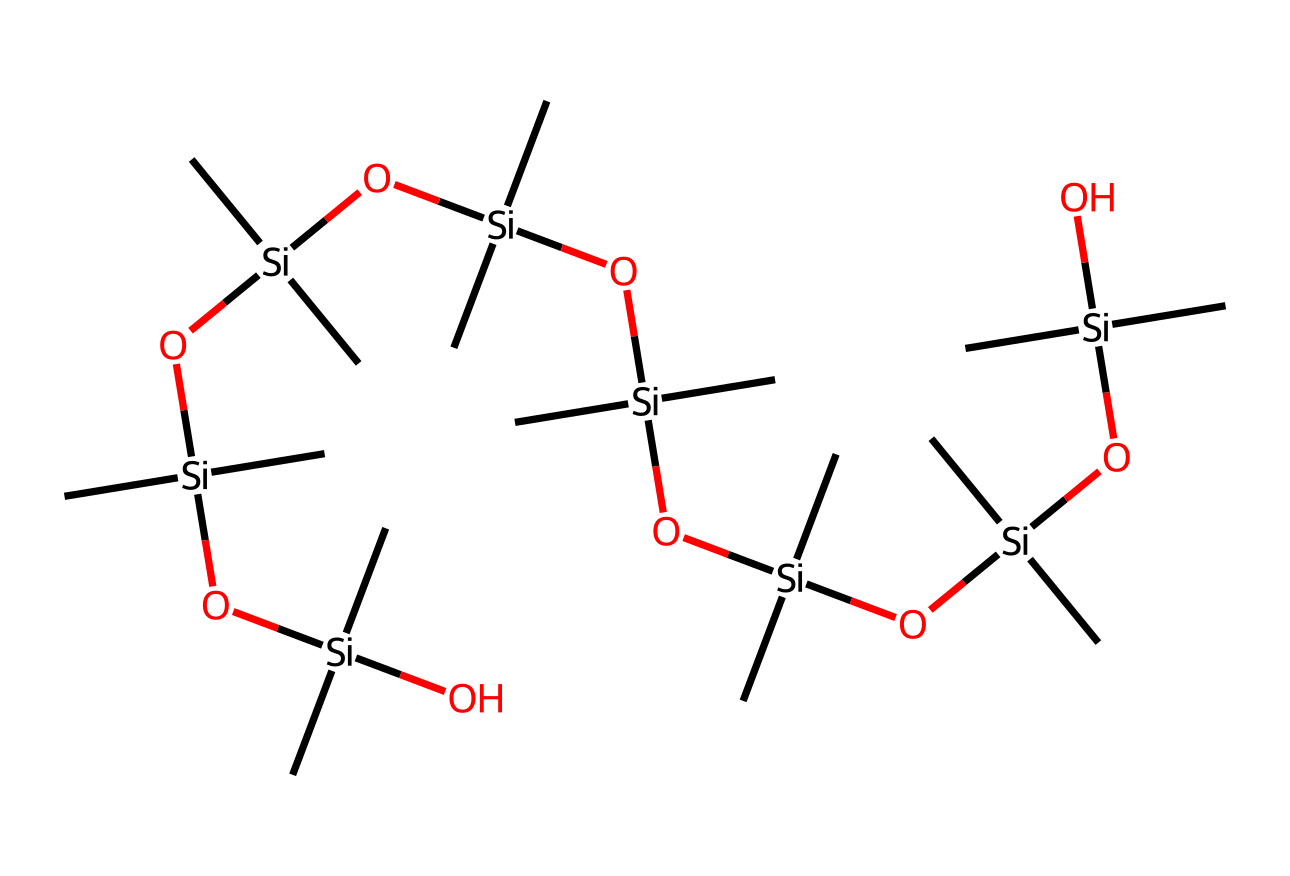What is the primary central atom in this organosilicon compound? Analyzing the SMILES representation, the central atom is silicon, which is noted multiple times within the structure.
Answer: silicon How many silicon atoms are present in this chemical structure? By counting the occurrences of 'Si' in the SMILES representation, there are five silicon atoms.
Answer: five What is the main functional group present in this compound? The presence of hydroxyl groups (-OH) attached to the silicon atoms indicates that this compound contains silanol functional groups.
Answer: silanol How many carbon atoms are in this compound? Upon examining the SMILES, each silicon is bonded to two methyl groups, resulting in a total of ten carbon atoms across five silicon centers.
Answer: ten What property does the presence of multiple bonds and branched structures in this compound suggest? The branching and multiple hydroxyl groups suggest that the compound is likely to have a high degree of flexibility and potentially good thermal stability, important for heat-resistant applications.
Answer: flexibility What type of silicon-based material is this compound likely categorized as? Given that it includes both silanol groups and branched silicon, this compound is categorized as a silicone elastomer, known for its elastomeric properties.
Answer: silicone elastomer 